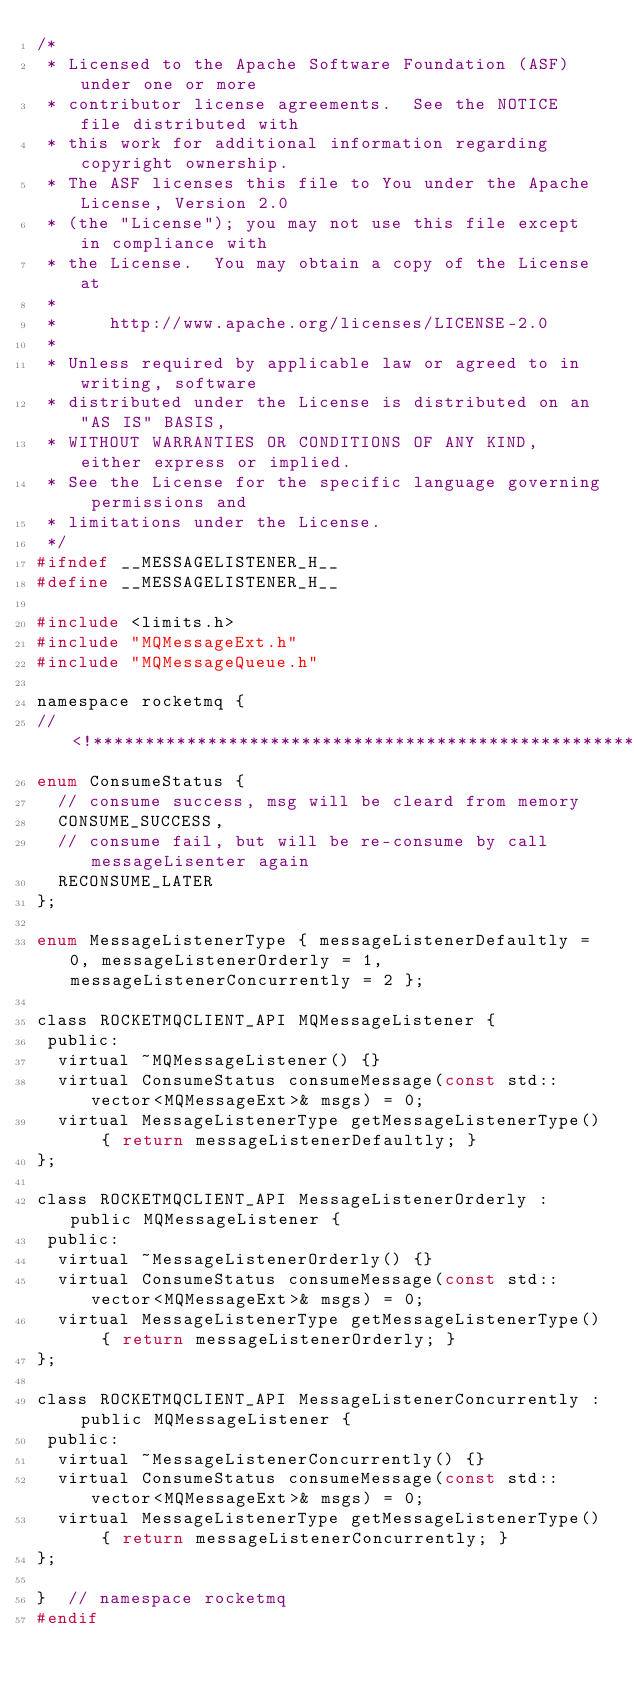Convert code to text. <code><loc_0><loc_0><loc_500><loc_500><_C_>/*
 * Licensed to the Apache Software Foundation (ASF) under one or more
 * contributor license agreements.  See the NOTICE file distributed with
 * this work for additional information regarding copyright ownership.
 * The ASF licenses this file to You under the Apache License, Version 2.0
 * (the "License"); you may not use this file except in compliance with
 * the License.  You may obtain a copy of the License at
 *
 *     http://www.apache.org/licenses/LICENSE-2.0
 *
 * Unless required by applicable law or agreed to in writing, software
 * distributed under the License is distributed on an "AS IS" BASIS,
 * WITHOUT WARRANTIES OR CONDITIONS OF ANY KIND, either express or implied.
 * See the License for the specific language governing permissions and
 * limitations under the License.
 */
#ifndef __MESSAGELISTENER_H__
#define __MESSAGELISTENER_H__

#include <limits.h>
#include "MQMessageExt.h"
#include "MQMessageQueue.h"

namespace rocketmq {
//<!***************************************************************************
enum ConsumeStatus {
  // consume success, msg will be cleard from memory
  CONSUME_SUCCESS,
  // consume fail, but will be re-consume by call messageLisenter again
  RECONSUME_LATER
};

enum MessageListenerType { messageListenerDefaultly = 0, messageListenerOrderly = 1, messageListenerConcurrently = 2 };

class ROCKETMQCLIENT_API MQMessageListener {
 public:
  virtual ~MQMessageListener() {}
  virtual ConsumeStatus consumeMessage(const std::vector<MQMessageExt>& msgs) = 0;
  virtual MessageListenerType getMessageListenerType() { return messageListenerDefaultly; }
};

class ROCKETMQCLIENT_API MessageListenerOrderly : public MQMessageListener {
 public:
  virtual ~MessageListenerOrderly() {}
  virtual ConsumeStatus consumeMessage(const std::vector<MQMessageExt>& msgs) = 0;
  virtual MessageListenerType getMessageListenerType() { return messageListenerOrderly; }
};

class ROCKETMQCLIENT_API MessageListenerConcurrently : public MQMessageListener {
 public:
  virtual ~MessageListenerConcurrently() {}
  virtual ConsumeStatus consumeMessage(const std::vector<MQMessageExt>& msgs) = 0;
  virtual MessageListenerType getMessageListenerType() { return messageListenerConcurrently; }
};

}  // namespace rocketmq
#endif
</code> 